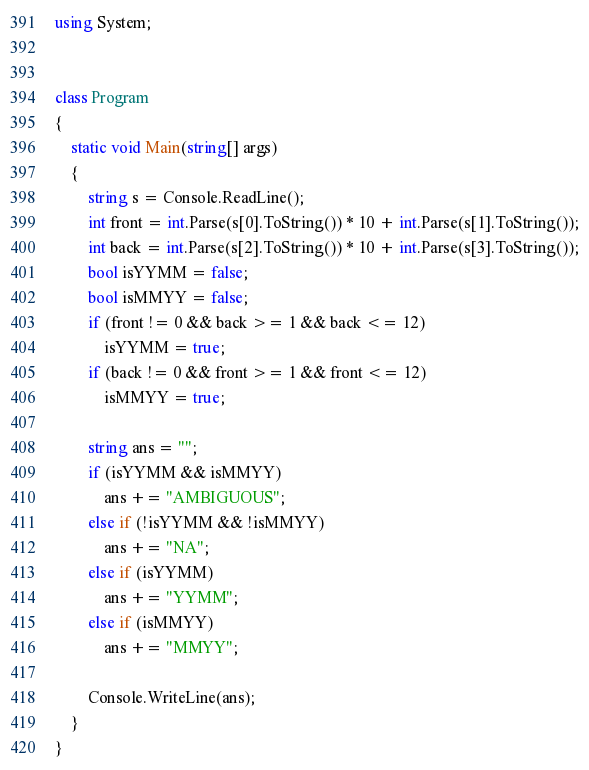<code> <loc_0><loc_0><loc_500><loc_500><_C#_>using System;


class Program
{
    static void Main(string[] args)
    {
        string s = Console.ReadLine();
        int front = int.Parse(s[0].ToString()) * 10 + int.Parse(s[1].ToString());
        int back = int.Parse(s[2].ToString()) * 10 + int.Parse(s[3].ToString());
        bool isYYMM = false;
        bool isMMYY = false;
        if (front != 0 && back >= 1 && back <= 12)
            isYYMM = true;
        if (back != 0 && front >= 1 && front <= 12)
            isMMYY = true;

        string ans = "";
        if (isYYMM && isMMYY)
            ans += "AMBIGUOUS";
        else if (!isYYMM && !isMMYY)
            ans += "NA";
        else if (isYYMM)
            ans += "YYMM";
        else if (isMMYY)
            ans += "MMYY";

        Console.WriteLine(ans);
    }
}</code> 